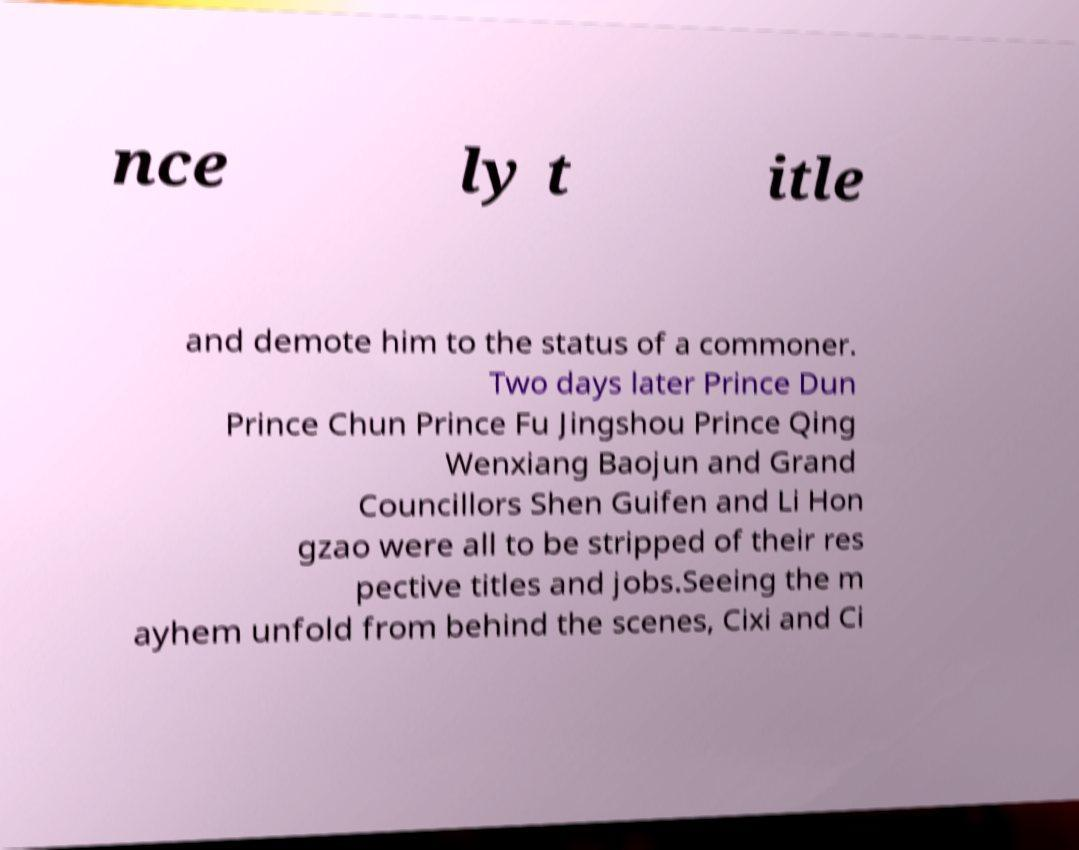For documentation purposes, I need the text within this image transcribed. Could you provide that? nce ly t itle and demote him to the status of a commoner. Two days later Prince Dun Prince Chun Prince Fu Jingshou Prince Qing Wenxiang Baojun and Grand Councillors Shen Guifen and Li Hon gzao were all to be stripped of their res pective titles and jobs.Seeing the m ayhem unfold from behind the scenes, Cixi and Ci 